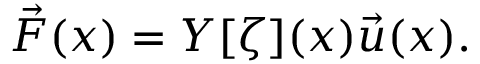<formula> <loc_0><loc_0><loc_500><loc_500>\begin{array} { r } { \vec { F } ( x ) = Y [ \zeta ] ( x ) \vec { u } ( x ) . } \end{array}</formula> 